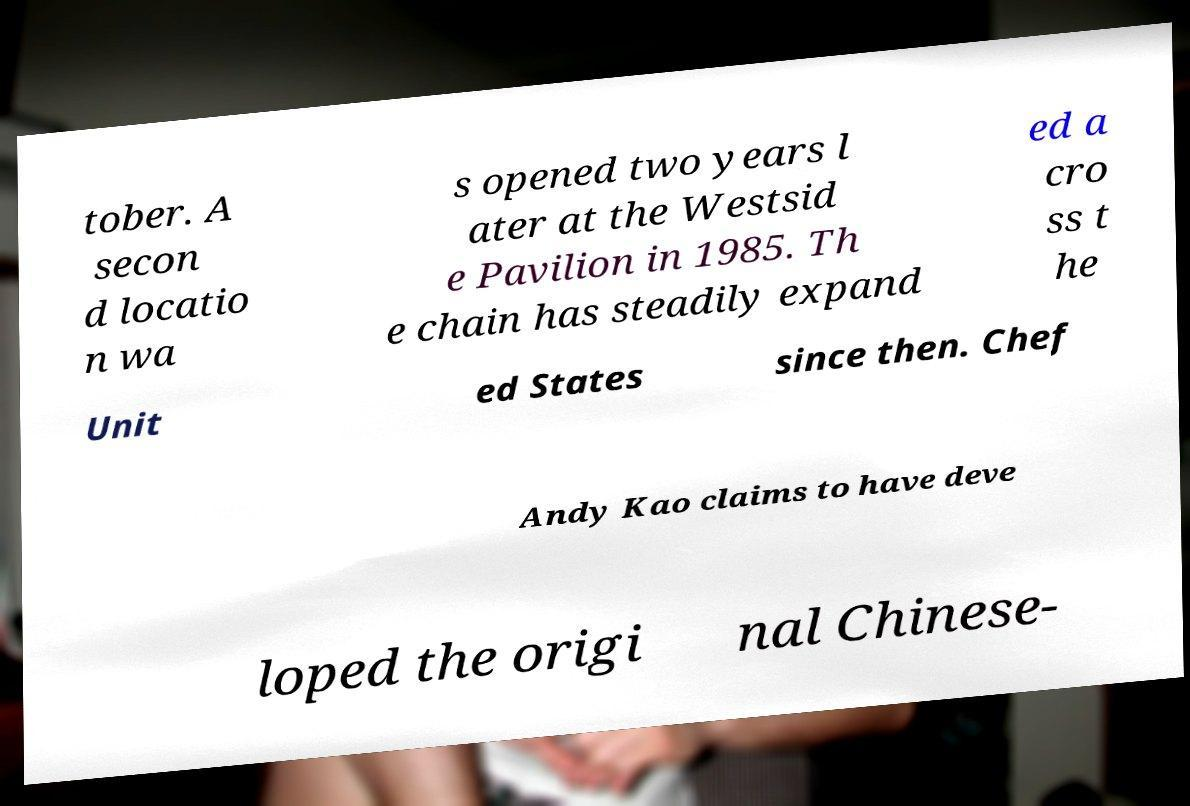Can you accurately transcribe the text from the provided image for me? tober. A secon d locatio n wa s opened two years l ater at the Westsid e Pavilion in 1985. Th e chain has steadily expand ed a cro ss t he Unit ed States since then. Chef Andy Kao claims to have deve loped the origi nal Chinese- 